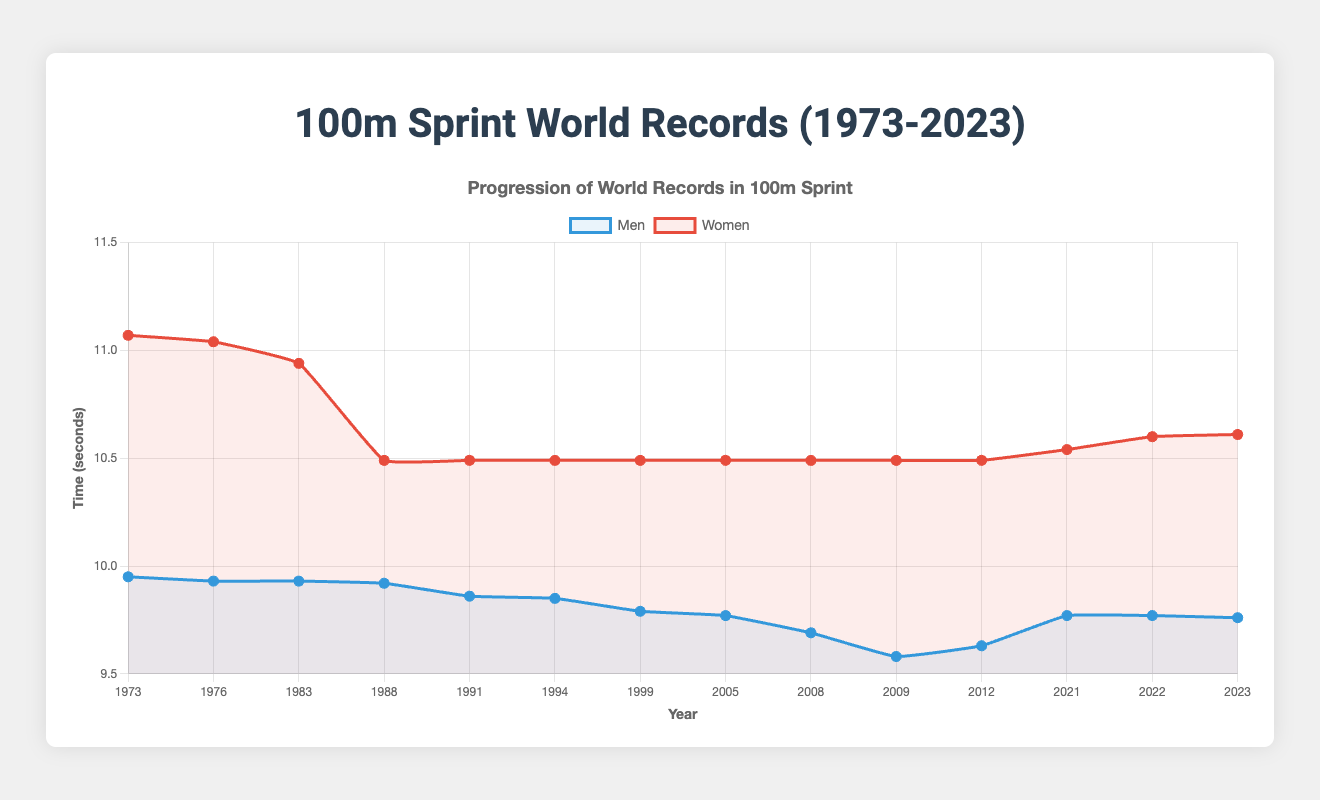What is the trend in men's world record times from 1973 to 2023? Observing the blue line representing men's records shows a general decrease in record times over the years, with the times improving from 9.95 seconds in 1973 to 9.76 seconds in 2023.
Answer: General decrease How many times has the women's 100m world record improved since 1973? Checking the red line representing women's records, it's clear that the record has improved three times: from 11.07 seconds to 11.04 seconds, then to 10.94 seconds, and finally to 10.49 seconds.
Answer: Three times Which athlete set the men's record in 2009, and what was the time? Referring to the data points, the tooltip for 2009 indicates Usain Bolt set the record at 9.58 seconds.
Answer: Usain Bolt, 9.58 seconds When did Florence Griffith-Joyner set the women's world record, and how long did it last? Florence Griffith-Joyner set the women's record at 10.49 seconds in 1988, and this time remained as the record until 2021, lasting 33 years.
Answer: 1988, 33 years Which period saw the largest improvement in men's 100m world records? The largest improvement for men's records occurred between 2008 and 2009, where Usain Bolt improved the record from 9.69 seconds to 9.58 seconds, a difference of 0.11 seconds.
Answer: 2008-2009 Compare the men's world record time in 1973 to the women's world record time in 2023. How much faster is the men's time? The men's record in 1973 was 9.95 seconds, and the women's record in 2023 was 10.61 seconds. The difference is 10.61 - 9.95 = 0.66 seconds.
Answer: 0.66 seconds faster Who was the athlete with the longest holding period of the women's 100m world record, and during which years? Florence Griffith-Joyner held the record from 1988 to 2021, totaling 33 years, the longest period for the women's record.
Answer: Florence Griffith-Joyner, 1988-2021 What is the average men's 100m world record time from 2008 to 2023? The men's record times from 2008 to 2023 are: 9.69, 9.58, 9.63, 9.77, 9.77, and 9.76. Adding these together gives (9.69 + 9.58 + 9.63 + 9.77 + 9.77 + 9.76) = 57.2 seconds. Dividing by 6 years, the average time is 57.2 / 6 = 9.53 seconds.
Answer: 9.53 seconds 